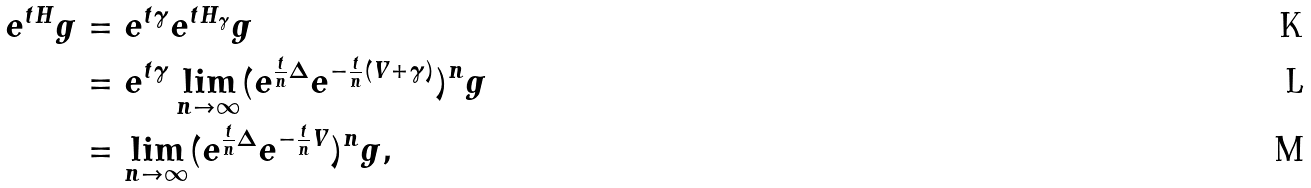<formula> <loc_0><loc_0><loc_500><loc_500>e ^ { t H } g & = e ^ { t \gamma } e ^ { t H _ { \gamma } } g \\ & = e ^ { t \gamma } \lim _ { n \to \infty } ( e ^ { \frac { t } { n } \Delta } e ^ { - \frac { t } { n } ( V + \gamma ) } ) ^ { n } g \\ & = \lim _ { n \to \infty } ( e ^ { \frac { t } { n } \Delta } e ^ { - \frac { t } { n } V } ) ^ { n } g ,</formula> 